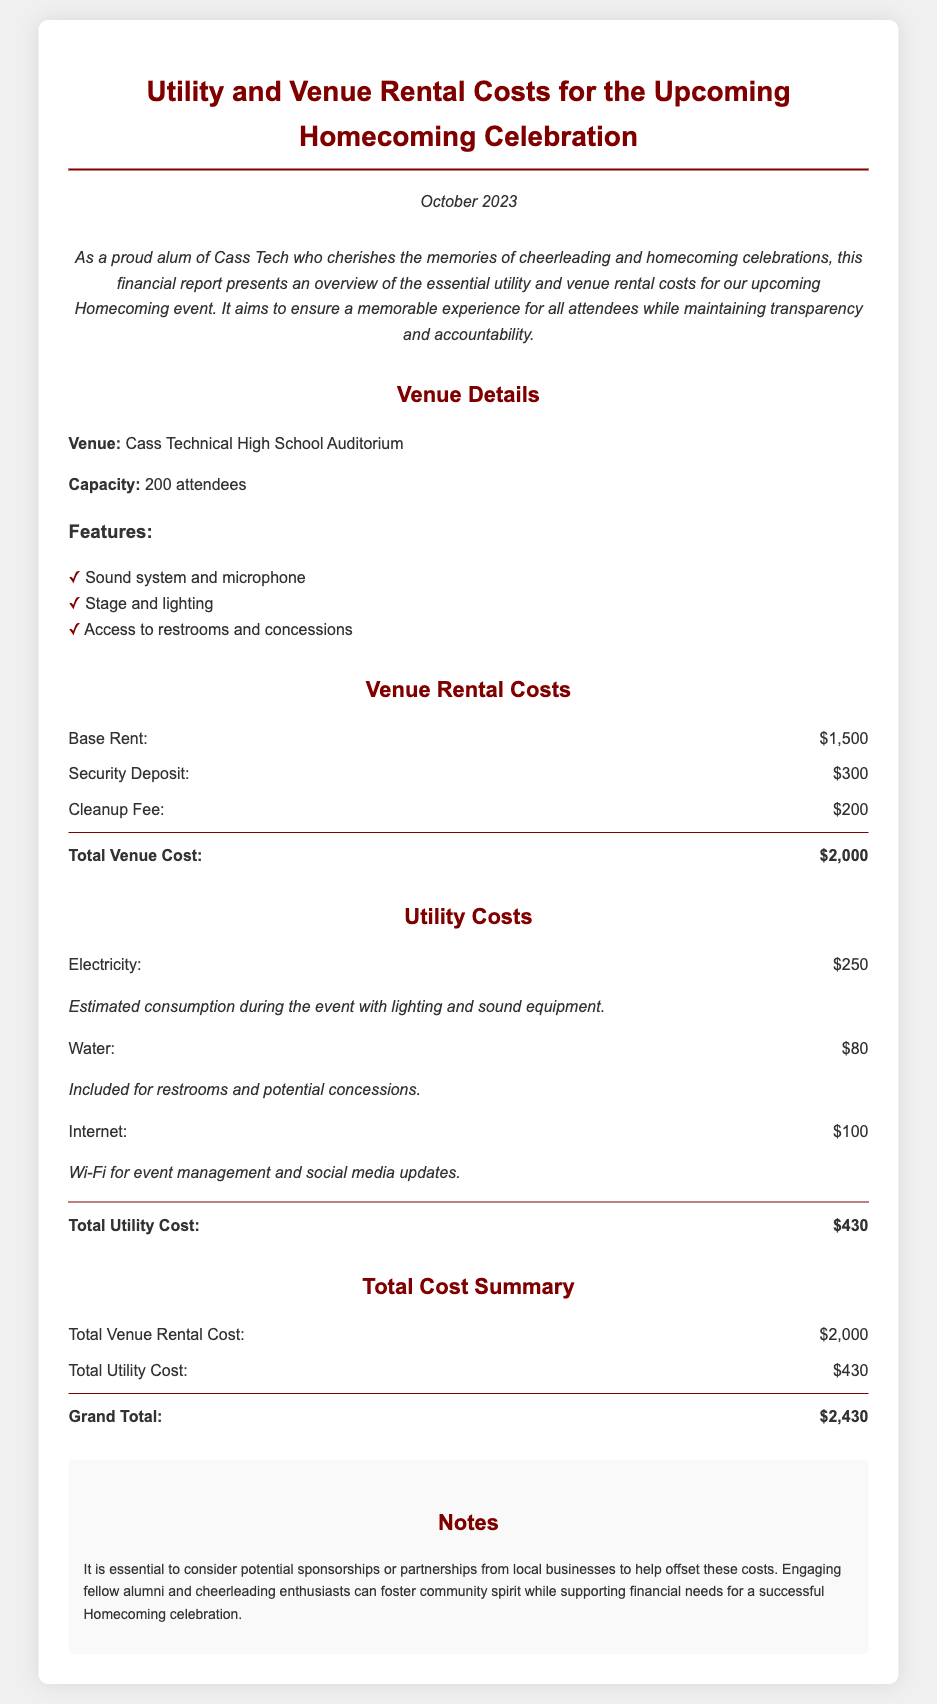What is the venue for the Homecoming Celebration? The venue for the Homecoming Celebration is mentioned in the document as Cass Technical High School Auditorium.
Answer: Cass Technical High School Auditorium What is the seating capacity of the venue? The document specifies the capacity of the venue for attendees, which is 200.
Answer: 200 What is the base rent for the venue? The base rent for the venue is listed under Venue Rental Costs in the document.
Answer: $1,500 What are the total utility costs? The total utility cost is provided in the Utility Costs section and is derived from the sum of individual utility expenses.
Answer: $430 What is the grand total for all costs associated with the Homecoming celebration? The grand total is summarized at the end of the document under Total Cost Summary.
Answer: $2,430 How much is the security deposit for the venue? The document explicitly mentions the amount for the security deposit in the Venue Rental Costs section.
Answer: $300 What is the cleanup fee? The cleanup fee is listed as a separate cost under Venue Rental Costs in the document.
Answer: $200 What could potentially help offset the costs of the Homecoming celebration? The document includes a note about consideration for something that could help with financial needs for the event.
Answer: Sponsorships or partnerships 